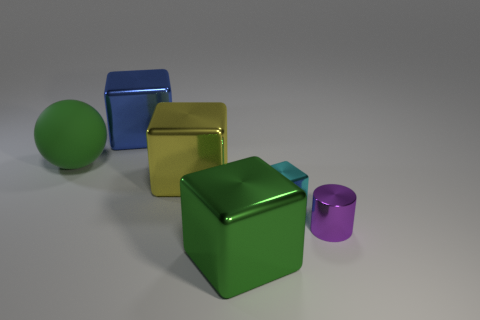What shape is the metallic object that is the same color as the rubber thing?
Give a very brief answer. Cube. The small block that is the same material as the large yellow object is what color?
Provide a succinct answer. Cyan. There is a thing that is both to the left of the large yellow block and right of the big matte object; how big is it?
Provide a short and direct response. Large. Is the number of tiny cyan cubes that are to the left of the yellow thing less than the number of blue metal objects that are in front of the matte object?
Your response must be concise. No. Do the large green thing on the left side of the yellow block and the green thing in front of the green matte sphere have the same material?
Your answer should be compact. No. What shape is the thing that is in front of the tiny cyan object and behind the large green metal block?
Offer a very short reply. Cylinder. What material is the big green object that is behind the block to the right of the green shiny object?
Keep it short and to the point. Rubber. Are there more tiny cyan things than tiny things?
Offer a very short reply. No. There is a green object that is the same size as the green block; what is it made of?
Your answer should be very brief. Rubber. Are the small cyan object and the big green sphere made of the same material?
Your answer should be compact. No. 